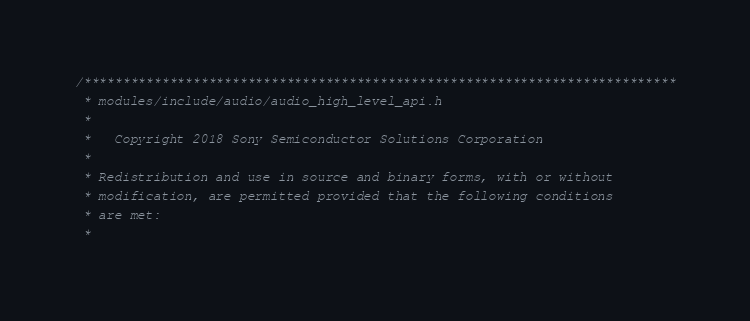Convert code to text. <code><loc_0><loc_0><loc_500><loc_500><_C_>/****************************************************************************
 * modules/include/audio/audio_high_level_api.h
 *
 *   Copyright 2018 Sony Semiconductor Solutions Corporation
 *
 * Redistribution and use in source and binary forms, with or without
 * modification, are permitted provided that the following conditions
 * are met:
 *</code> 